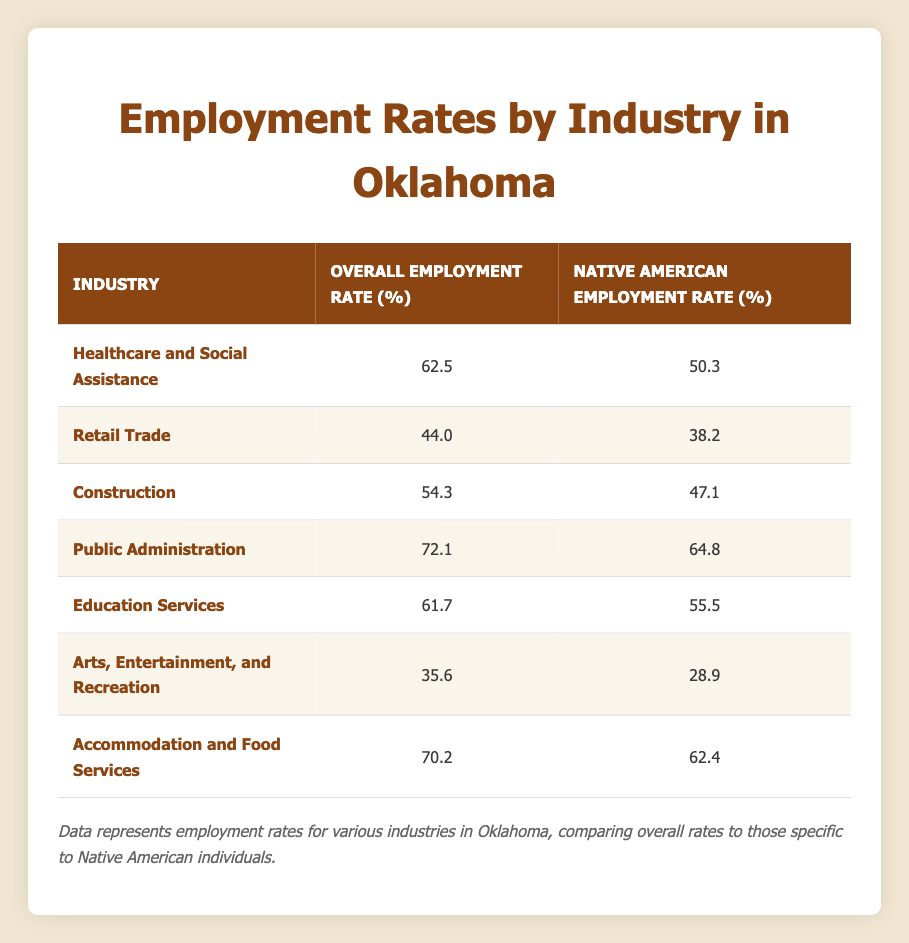What is the employment rate for the Public Administration industry? Referring to the table, the employment rate listed for the Public Administration industry is directly noted under the "Overall Employment Rate (%)" column. It shows 72.1%.
Answer: 72.1 What is the Native American employment rate in the Arts, Entertainment, and Recreation industry? The table specifies the Native American employment rate in the Arts, Entertainment, and Recreation industry, which is noted as 28.9% in the appropriate column.
Answer: 28.9 Which industry has the highest Native American employment rate? By examining the Native American employment rates listed, Public Administration at 64.8% has the highest rate compared to the others.
Answer: Public Administration What is the difference between the healthcare employment rate for all individuals and Native American individuals? The overall healthcare employment rate is 62.5%, while for Native Americans it is 50.3%. To find the difference, subtract the two values: 62.5 - 50.3 = 12.2%. Thus, the difference is 12.2%.
Answer: 12.2 Is the Native American employment rate in Accommodation and Food Services higher than in Arts, Entertainment, and Recreation? Comparing the Native American employment rates, Accommodation and Food Services has a rate of 62.4%, while Arts, Entertainment, and Recreation has 28.9%. Since 62.4% is greater than 28.9%, the statement is true.
Answer: Yes What is the average Native American employment rate across all industries listed? To find the average, sum the Native American employment rates: 50.3 + 38.2 + 47.1 + 64.8 + 55.5 + 28.9 + 62.4 = 347.3. Since there are 7 industries, divide the total by 7: 347.3 / 7 ≈ 49.6%.
Answer: 49.6 Does the Retail Trade have a higher overall employment rate than the Construction industry? The overall employment rate for Retail Trade is 44.0%, while for Construction it is 54.3%. Comparing the two shows that 44.0% is less than 54.3%, making the statement false.
Answer: No Which industry has the lowest overall employment rate? By reviewing the overall employment rates in the table, Arts, Entertainment, and Recreation lists the lowest rate at 35.6%.
Answer: Arts, Entertainment, and Recreation How much greater is the overall employment rate in Accommodation and Food Services compared to the Healthcare and Social Assistance industry? The overall employment rate for Accommodation and Food Services is 70.2%, and for Healthcare and Social Assistance, it is 62.5%. Subtract the latter from the former: 70.2 - 62.5 = 7.7%. Thus, Accommodation and Food Services has an employment rate that is 7.7% greater.
Answer: 7.7 